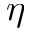Convert formula to latex. <formula><loc_0><loc_0><loc_500><loc_500>\eta</formula> 